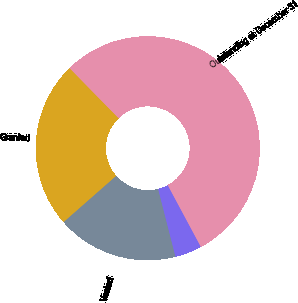Convert chart. <chart><loc_0><loc_0><loc_500><loc_500><pie_chart><fcel>Outstanding at December 31<fcel>Granted<fcel>Vested<fcel>Forfeited<nl><fcel>54.49%<fcel>24.14%<fcel>17.52%<fcel>3.85%<nl></chart> 